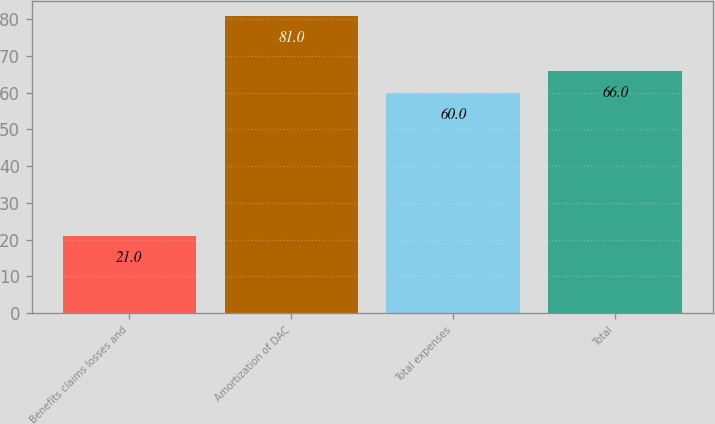Convert chart to OTSL. <chart><loc_0><loc_0><loc_500><loc_500><bar_chart><fcel>Benefits claims losses and<fcel>Amortization of DAC<fcel>Total expenses<fcel>Total<nl><fcel>21<fcel>81<fcel>60<fcel>66<nl></chart> 